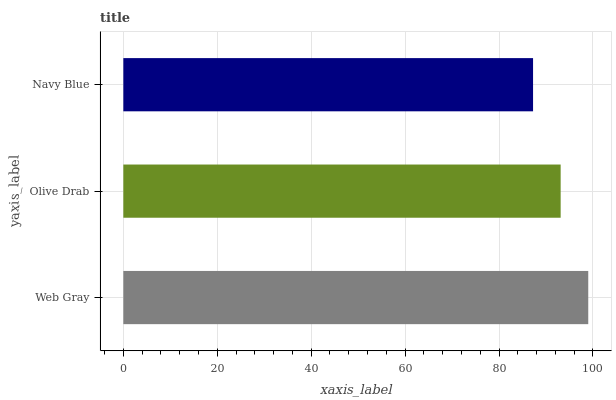Is Navy Blue the minimum?
Answer yes or no. Yes. Is Web Gray the maximum?
Answer yes or no. Yes. Is Olive Drab the minimum?
Answer yes or no. No. Is Olive Drab the maximum?
Answer yes or no. No. Is Web Gray greater than Olive Drab?
Answer yes or no. Yes. Is Olive Drab less than Web Gray?
Answer yes or no. Yes. Is Olive Drab greater than Web Gray?
Answer yes or no. No. Is Web Gray less than Olive Drab?
Answer yes or no. No. Is Olive Drab the high median?
Answer yes or no. Yes. Is Olive Drab the low median?
Answer yes or no. Yes. Is Web Gray the high median?
Answer yes or no. No. Is Web Gray the low median?
Answer yes or no. No. 